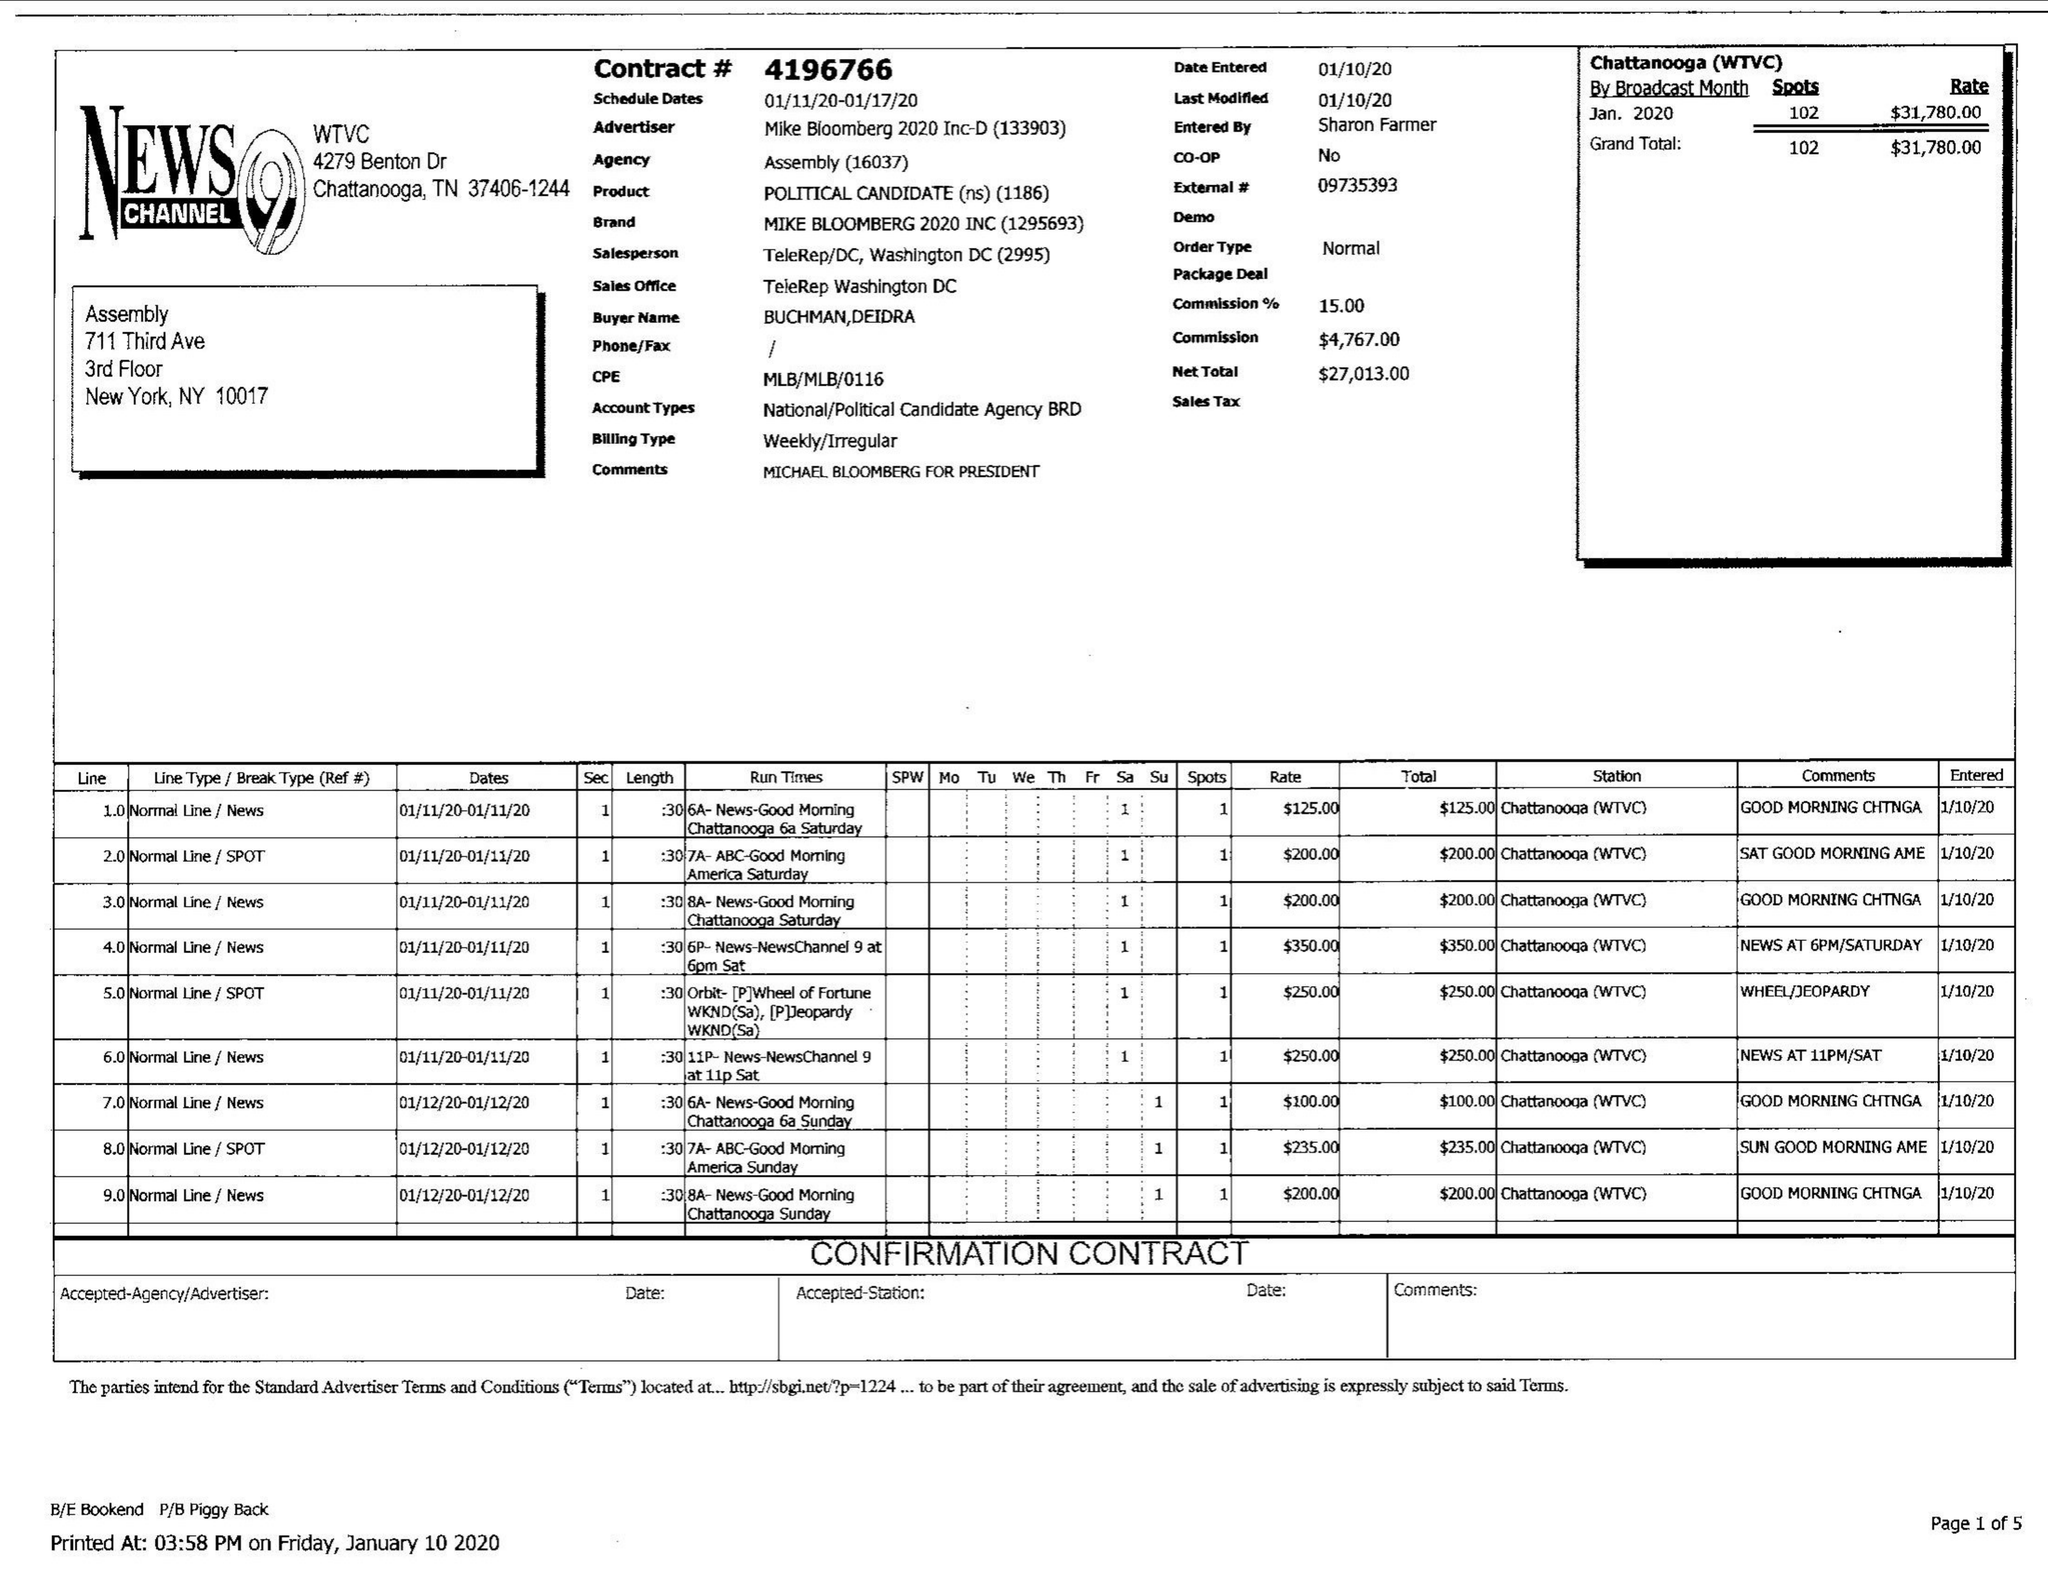What is the value for the contract_num?
Answer the question using a single word or phrase. 4196766 